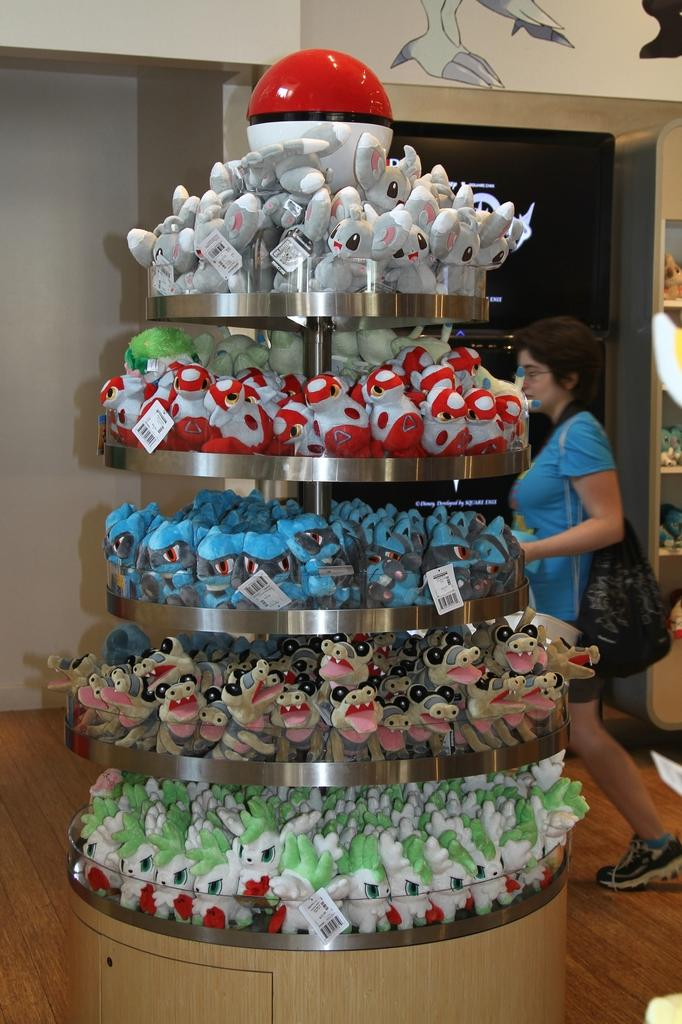What can be found in the stand in the image? There are toys in the stand in the image. What is the woman in the image doing? The woman is walking in the image. What is the woman holding in the image? The woman is holding a bag in the image. What can be seen on the wall in the image? There is a painting on the wall in the image. How much does the wax figure weigh in the image? There is no wax figure present in the image. What advice does the woman's grandfather give her in the image? There is no mention of a grandfather or any advice in the image. 